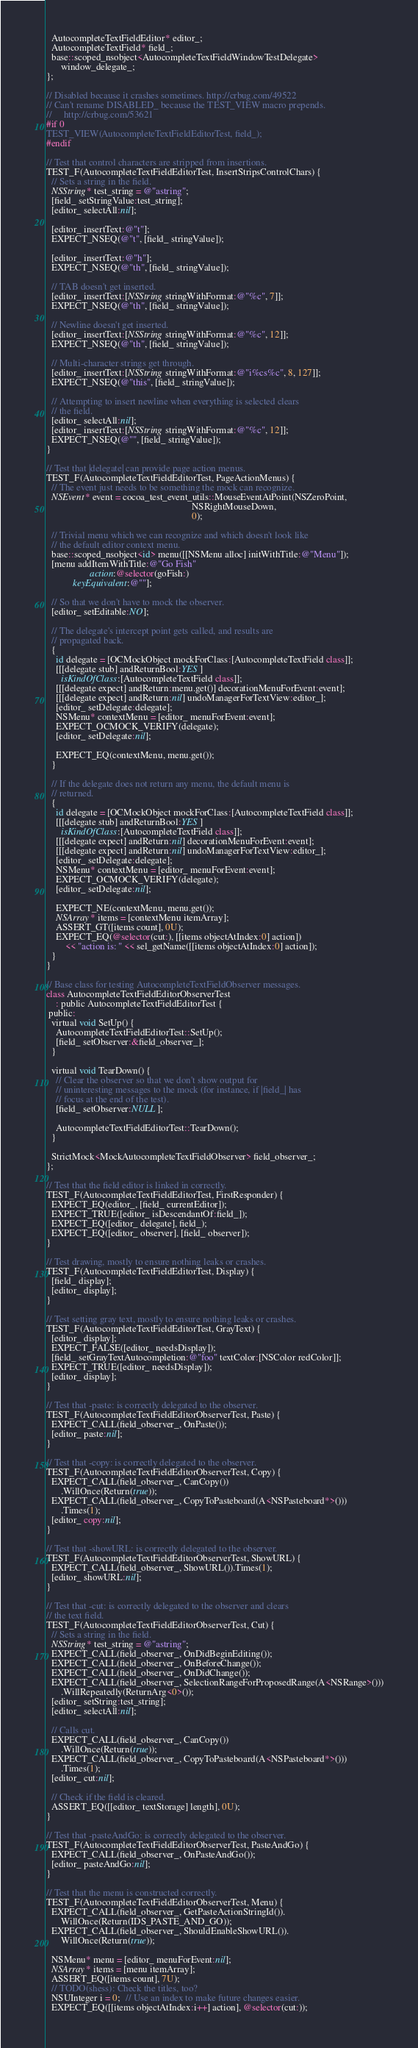<code> <loc_0><loc_0><loc_500><loc_500><_ObjectiveC_>  AutocompleteTextFieldEditor* editor_;
  AutocompleteTextField* field_;
  base::scoped_nsobject<AutocompleteTextFieldWindowTestDelegate>
      window_delegate_;
};

// Disabled because it crashes sometimes. http://crbug.com/49522
// Can't rename DISABLED_ because the TEST_VIEW macro prepends.
//     http://crbug.com/53621
#if 0
TEST_VIEW(AutocompleteTextFieldEditorTest, field_);
#endif

// Test that control characters are stripped from insertions.
TEST_F(AutocompleteTextFieldEditorTest, InsertStripsControlChars) {
  // Sets a string in the field.
  NSString* test_string = @"astring";
  [field_ setStringValue:test_string];
  [editor_ selectAll:nil];

  [editor_ insertText:@"t"];
  EXPECT_NSEQ(@"t", [field_ stringValue]);

  [editor_ insertText:@"h"];
  EXPECT_NSEQ(@"th", [field_ stringValue]);

  // TAB doesn't get inserted.
  [editor_ insertText:[NSString stringWithFormat:@"%c", 7]];
  EXPECT_NSEQ(@"th", [field_ stringValue]);

  // Newline doesn't get inserted.
  [editor_ insertText:[NSString stringWithFormat:@"%c", 12]];
  EXPECT_NSEQ(@"th", [field_ stringValue]);

  // Multi-character strings get through.
  [editor_ insertText:[NSString stringWithFormat:@"i%cs%c", 8, 127]];
  EXPECT_NSEQ(@"this", [field_ stringValue]);

  // Attempting to insert newline when everything is selected clears
  // the field.
  [editor_ selectAll:nil];
  [editor_ insertText:[NSString stringWithFormat:@"%c", 12]];
  EXPECT_NSEQ(@"", [field_ stringValue]);
}

// Test that |delegate| can provide page action menus.
TEST_F(AutocompleteTextFieldEditorTest, PageActionMenus) {
  // The event just needs to be something the mock can recognize.
  NSEvent* event = cocoa_test_event_utils::MouseEventAtPoint(NSZeroPoint,
                                                             NSRightMouseDown,
                                                             0);

  // Trivial menu which we can recognize and which doesn't look like
  // the default editor context menu.
  base::scoped_nsobject<id> menu([[NSMenu alloc] initWithTitle:@"Menu"]);
  [menu addItemWithTitle:@"Go Fish"
                  action:@selector(goFish:)
           keyEquivalent:@""];

  // So that we don't have to mock the observer.
  [editor_ setEditable:NO];

  // The delegate's intercept point gets called, and results are
  // propagated back.
  {
    id delegate = [OCMockObject mockForClass:[AutocompleteTextField class]];
    [[[delegate stub] andReturnBool:YES]
      isKindOfClass:[AutocompleteTextField class]];
    [[[delegate expect] andReturn:menu.get()] decorationMenuForEvent:event];
    [[[delegate expect] andReturn:nil] undoManagerForTextView:editor_];
    [editor_ setDelegate:delegate];
    NSMenu* contextMenu = [editor_ menuForEvent:event];
    EXPECT_OCMOCK_VERIFY(delegate);
    [editor_ setDelegate:nil];

    EXPECT_EQ(contextMenu, menu.get());
  }

  // If the delegate does not return any menu, the default menu is
  // returned.
  {
    id delegate = [OCMockObject mockForClass:[AutocompleteTextField class]];
    [[[delegate stub] andReturnBool:YES]
      isKindOfClass:[AutocompleteTextField class]];
    [[[delegate expect] andReturn:nil] decorationMenuForEvent:event];
    [[[delegate expect] andReturn:nil] undoManagerForTextView:editor_];
    [editor_ setDelegate:delegate];
    NSMenu* contextMenu = [editor_ menuForEvent:event];
    EXPECT_OCMOCK_VERIFY(delegate);
    [editor_ setDelegate:nil];

    EXPECT_NE(contextMenu, menu.get());
    NSArray* items = [contextMenu itemArray];
    ASSERT_GT([items count], 0U);
    EXPECT_EQ(@selector(cut:), [[items objectAtIndex:0] action])
        << "action is: " << sel_getName([[items objectAtIndex:0] action]);
  }
}

// Base class for testing AutocompleteTextFieldObserver messages.
class AutocompleteTextFieldEditorObserverTest
    : public AutocompleteTextFieldEditorTest {
 public:
  virtual void SetUp() {
    AutocompleteTextFieldEditorTest::SetUp();
    [field_ setObserver:&field_observer_];
  }

  virtual void TearDown() {
    // Clear the observer so that we don't show output for
    // uninteresting messages to the mock (for instance, if |field_| has
    // focus at the end of the test).
    [field_ setObserver:NULL];

    AutocompleteTextFieldEditorTest::TearDown();
  }

  StrictMock<MockAutocompleteTextFieldObserver> field_observer_;
};

// Test that the field editor is linked in correctly.
TEST_F(AutocompleteTextFieldEditorTest, FirstResponder) {
  EXPECT_EQ(editor_, [field_ currentEditor]);
  EXPECT_TRUE([editor_ isDescendantOf:field_]);
  EXPECT_EQ([editor_ delegate], field_);
  EXPECT_EQ([editor_ observer], [field_ observer]);
}

// Test drawing, mostly to ensure nothing leaks or crashes.
TEST_F(AutocompleteTextFieldEditorTest, Display) {
  [field_ display];
  [editor_ display];
}

// Test setting gray text, mostly to ensure nothing leaks or crashes.
TEST_F(AutocompleteTextFieldEditorTest, GrayText) {
  [editor_ display];
  EXPECT_FALSE([editor_ needsDisplay]);
  [field_ setGrayTextAutocompletion:@"foo" textColor:[NSColor redColor]];
  EXPECT_TRUE([editor_ needsDisplay]);
  [editor_ display];
}

// Test that -paste: is correctly delegated to the observer.
TEST_F(AutocompleteTextFieldEditorObserverTest, Paste) {
  EXPECT_CALL(field_observer_, OnPaste());
  [editor_ paste:nil];
}

// Test that -copy: is correctly delegated to the observer.
TEST_F(AutocompleteTextFieldEditorObserverTest, Copy) {
  EXPECT_CALL(field_observer_, CanCopy())
      .WillOnce(Return(true));
  EXPECT_CALL(field_observer_, CopyToPasteboard(A<NSPasteboard*>()))
      .Times(1);
  [editor_ copy:nil];
}

// Test that -showURL: is correctly delegated to the observer.
TEST_F(AutocompleteTextFieldEditorObserverTest, ShowURL) {
  EXPECT_CALL(field_observer_, ShowURL()).Times(1);
  [editor_ showURL:nil];
}

// Test that -cut: is correctly delegated to the observer and clears
// the text field.
TEST_F(AutocompleteTextFieldEditorObserverTest, Cut) {
  // Sets a string in the field.
  NSString* test_string = @"astring";
  EXPECT_CALL(field_observer_, OnDidBeginEditing());
  EXPECT_CALL(field_observer_, OnBeforeChange());
  EXPECT_CALL(field_observer_, OnDidChange());
  EXPECT_CALL(field_observer_, SelectionRangeForProposedRange(A<NSRange>()))
      .WillRepeatedly(ReturnArg<0>());
  [editor_ setString:test_string];
  [editor_ selectAll:nil];

  // Calls cut.
  EXPECT_CALL(field_observer_, CanCopy())
      .WillOnce(Return(true));
  EXPECT_CALL(field_observer_, CopyToPasteboard(A<NSPasteboard*>()))
      .Times(1);
  [editor_ cut:nil];

  // Check if the field is cleared.
  ASSERT_EQ([[editor_ textStorage] length], 0U);
}

// Test that -pasteAndGo: is correctly delegated to the observer.
TEST_F(AutocompleteTextFieldEditorObserverTest, PasteAndGo) {
  EXPECT_CALL(field_observer_, OnPasteAndGo());
  [editor_ pasteAndGo:nil];
}

// Test that the menu is constructed correctly.
TEST_F(AutocompleteTextFieldEditorObserverTest, Menu) {
  EXPECT_CALL(field_observer_, GetPasteActionStringId()).
      WillOnce(Return(IDS_PASTE_AND_GO));
  EXPECT_CALL(field_observer_, ShouldEnableShowURL()).
      WillOnce(Return(true));

  NSMenu* menu = [editor_ menuForEvent:nil];
  NSArray* items = [menu itemArray];
  ASSERT_EQ([items count], 7U);
  // TODO(shess): Check the titles, too?
  NSUInteger i = 0;  // Use an index to make future changes easier.
  EXPECT_EQ([[items objectAtIndex:i++] action], @selector(cut:));</code> 